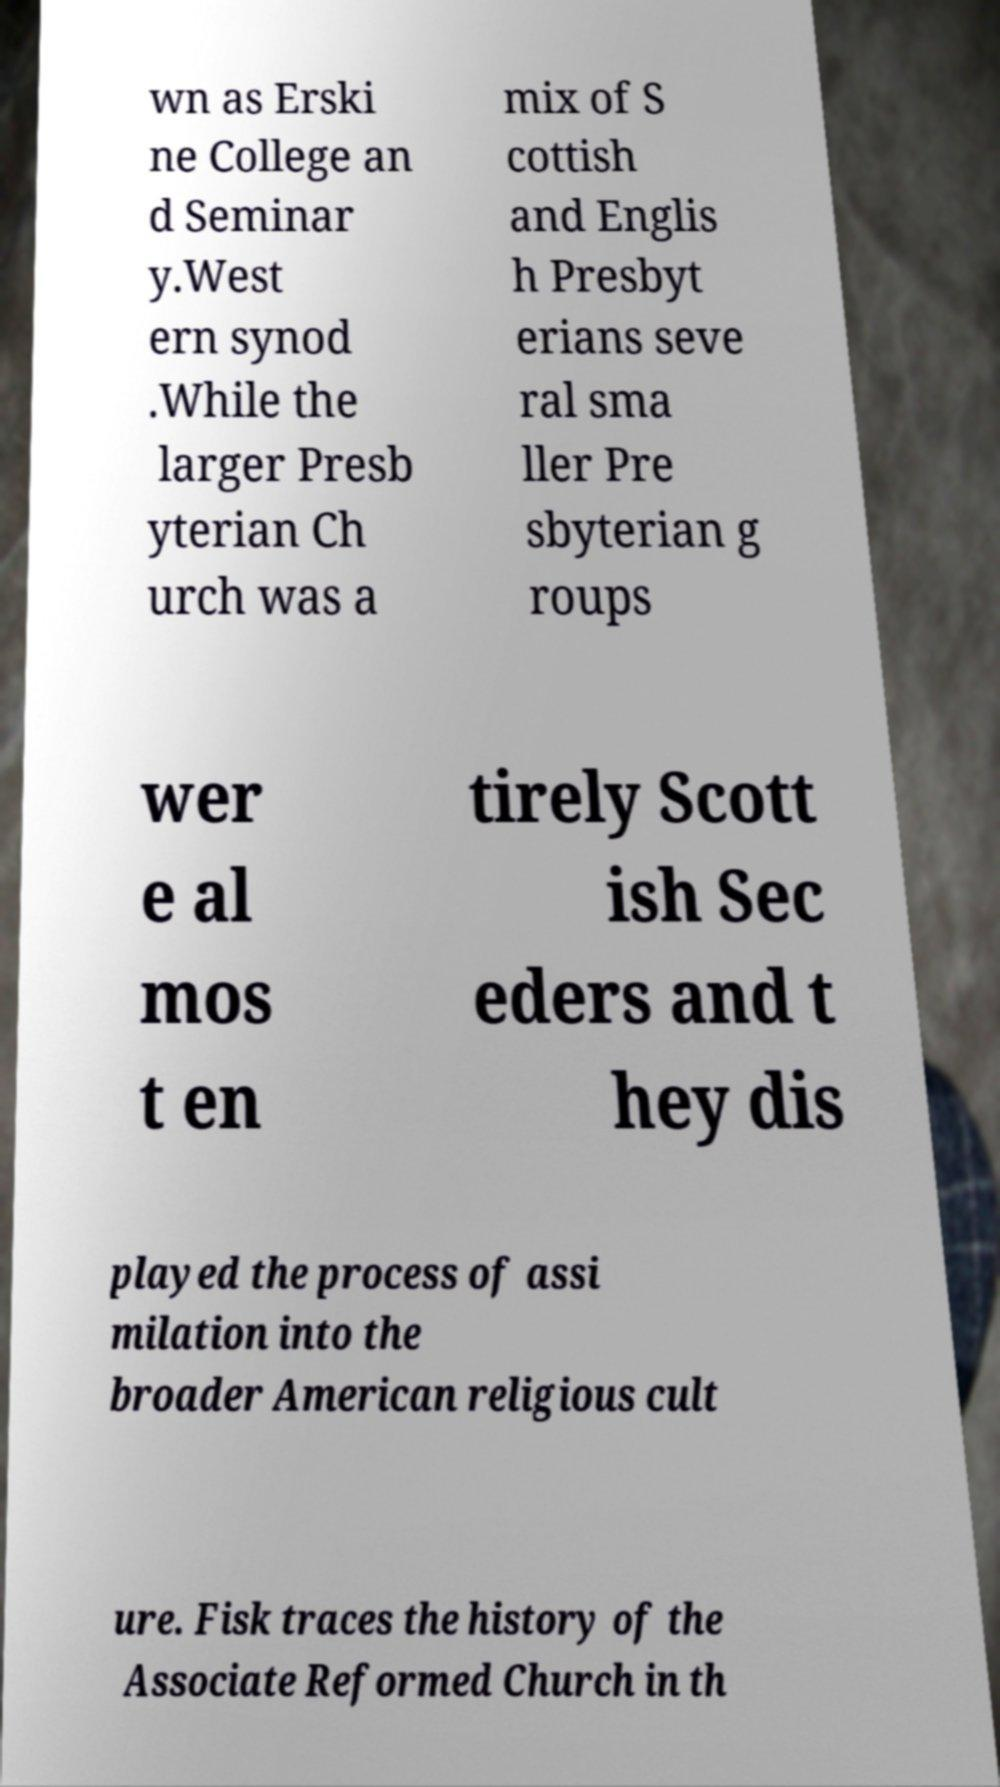I need the written content from this picture converted into text. Can you do that? wn as Erski ne College an d Seminar y.West ern synod .While the larger Presb yterian Ch urch was a mix of S cottish and Englis h Presbyt erians seve ral sma ller Pre sbyterian g roups wer e al mos t en tirely Scott ish Sec eders and t hey dis played the process of assi milation into the broader American religious cult ure. Fisk traces the history of the Associate Reformed Church in th 